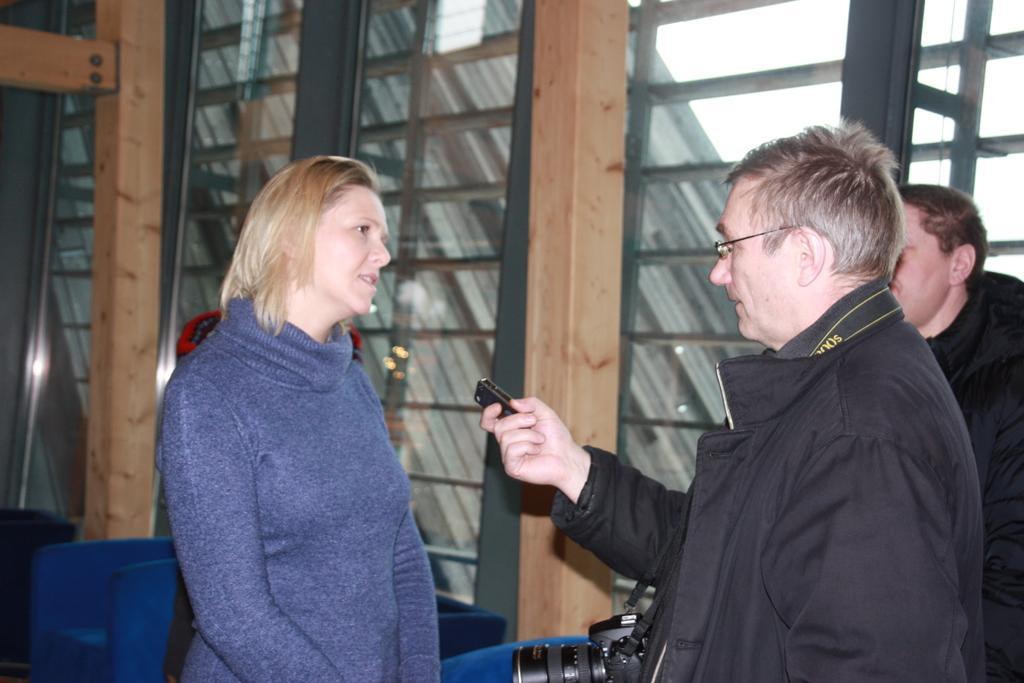In one or two sentences, can you explain what this image depicts? There are people standing and this person wore camera and holding a object. Background we can see glass windows,through these windows we can see sky. 